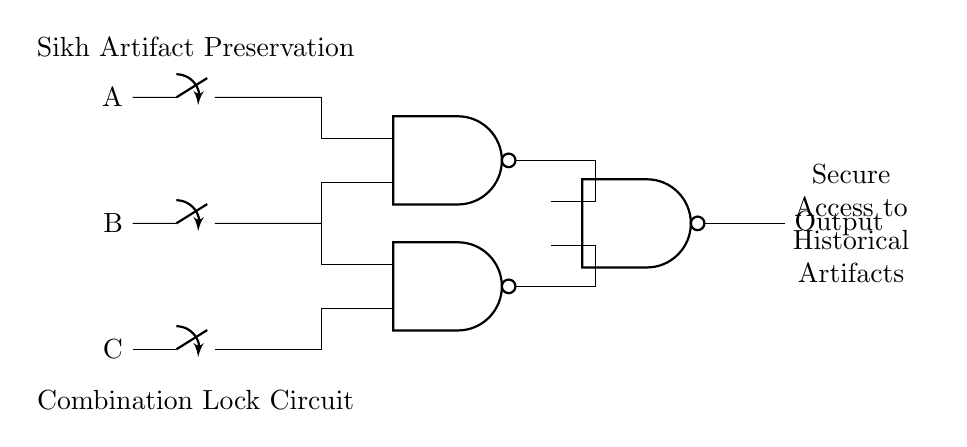What are the inputs to the circuit? The inputs to the circuit are labeled as A, B, and C, which are represented by switches.
Answer: A, B, C How many NAND gates are in the circuit? There are three NAND gates shown in the circuit diagram indicating logical operations.
Answer: 3 What does the output represent? The output reflects the secure access mechanism for the preservation of historical Sikh artifacts. It provides a condition based on the inputs processed through the NAND gates.
Answer: Output What logical operation do the gates perform? The gates perform the NAND logic operation, which outputs false only when both inputs are true.
Answer: NAND What is the purpose of using a combination lock in this circuit? The combination lock, represented by the switches A, B, and C, is used to securely access artifacts by controlling when the output is activated, thus ensuring only authorized access.
Answer: Secure Access How many total connections are made to the NAND gates from the input switches? Each NAND gate has two inputs, and there are six total connections from the three switches (two to the first gate and two to the second, plus the outputs to the third gate).
Answer: 6 